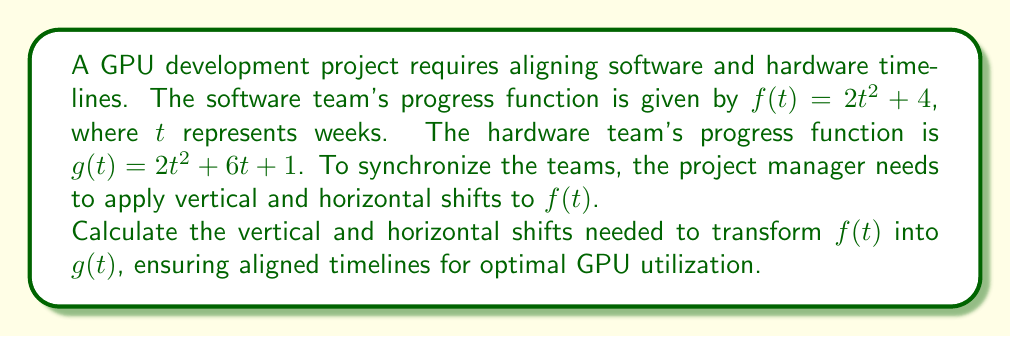Teach me how to tackle this problem. To align the software team's progress function $f(t)$ with the hardware team's progress function $g(t)$, we need to determine the horizontal and vertical shifts. Let's approach this step-by-step:

1) The general form of a function with horizontal shift $h$ and vertical shift $k$ is:
   $$f(t-h) + k$$

2) We need to transform $f(t) = 2t^2 + 4$ into $g(t) = 2t^2 + 6t + 1$

3) First, let's focus on the quadratic term. Both functions have $2t^2$, so no scaling is needed.

4) For the horizontal shift, we need to complete the square for $g(t)$:
   $$g(t) = 2t^2 + 6t + 1$$
   $$= 2(t^2 + 3t) + 1$$
   $$= 2(t^2 + 3t + \frac{9}{4} - \frac{9}{4}) + 1$$
   $$= 2(t + \frac{3}{2})^2 - \frac{9}{2} + 1$$
   $$= 2(t + \frac{3}{2})^2 - \frac{7}{2}$$

5) Comparing this to $f(t-h)$, we can see that $h = -\frac{3}{2}$

6) For the vertical shift, we compare the constant terms:
   $f(t)$ has a constant term of 4
   $g(t)$ in its completed square form has a constant term of $-\frac{7}{2}$
   
   The vertical shift $k$ is the difference: $-\frac{7}{2} - 4 = -\frac{15}{2}$

Therefore, to transform $f(t)$ into $g(t)$, we need to shift $f(t)$ horizontally by $-\frac{3}{2}$ units (left) and vertically by $-\frac{15}{2}$ units (down).
Answer: Horizontal shift: $h = -\frac{3}{2}$ (left)
Vertical shift: $k = -\frac{15}{2}$ (down) 